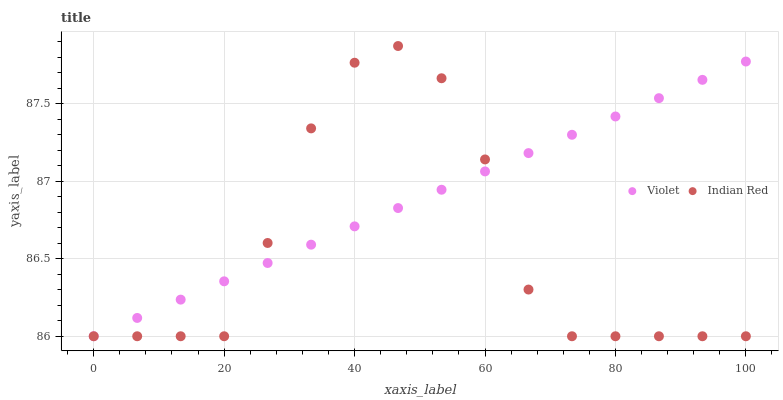Does Indian Red have the minimum area under the curve?
Answer yes or no. Yes. Does Violet have the maximum area under the curve?
Answer yes or no. Yes. Does Violet have the minimum area under the curve?
Answer yes or no. No. Is Violet the smoothest?
Answer yes or no. Yes. Is Indian Red the roughest?
Answer yes or no. Yes. Is Violet the roughest?
Answer yes or no. No. Does Indian Red have the lowest value?
Answer yes or no. Yes. Does Indian Red have the highest value?
Answer yes or no. Yes. Does Violet have the highest value?
Answer yes or no. No. Does Violet intersect Indian Red?
Answer yes or no. Yes. Is Violet less than Indian Red?
Answer yes or no. No. Is Violet greater than Indian Red?
Answer yes or no. No. 